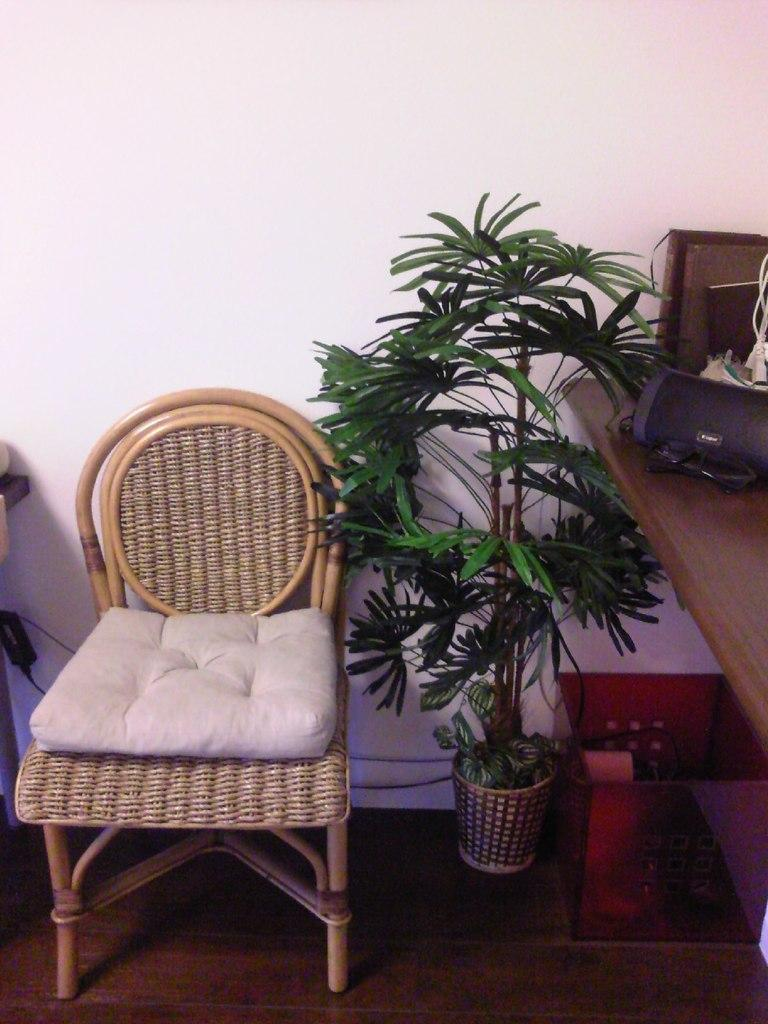What type of furniture is in the image? There is a chair in the image. What is on the chair? The chair has a pillow. What type of living organism is in the image? There is a plant in the image. What is the container used for? The purpose of the container is not specified, but it is present in the image. What is the table used for? The table is used to hold things, as there are things on the table. What type of test is being conducted in the image? There is no test being conducted in the image; it features a chair, a pillow, a plant, a container, a table, and things on the table. What is the patch used for in the image? There is no patch present in the image. 